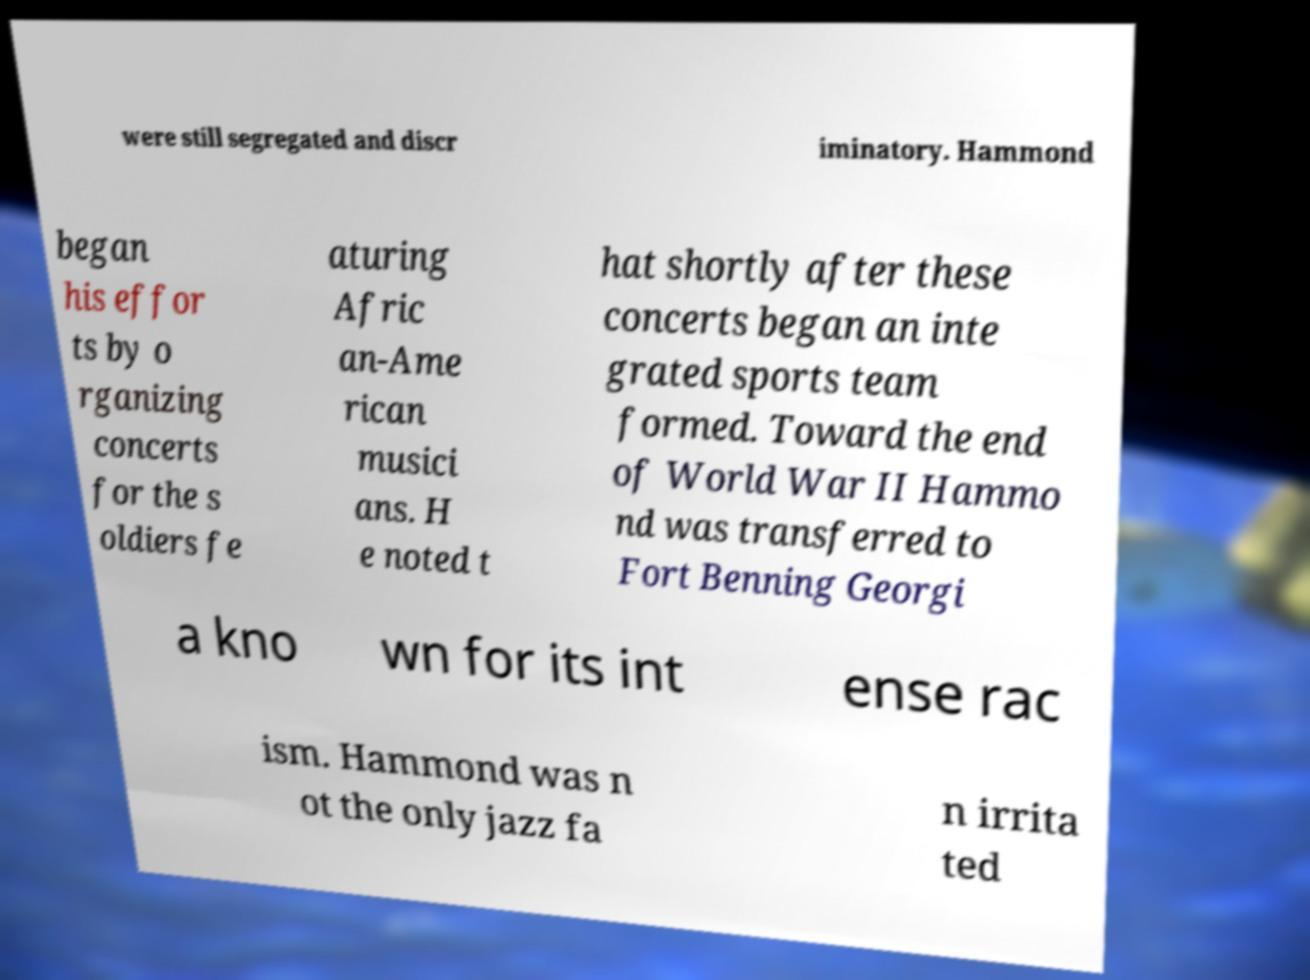Can you accurately transcribe the text from the provided image for me? were still segregated and discr iminatory. Hammond began his effor ts by o rganizing concerts for the s oldiers fe aturing Afric an-Ame rican musici ans. H e noted t hat shortly after these concerts began an inte grated sports team formed. Toward the end of World War II Hammo nd was transferred to Fort Benning Georgi a kno wn for its int ense rac ism. Hammond was n ot the only jazz fa n irrita ted 